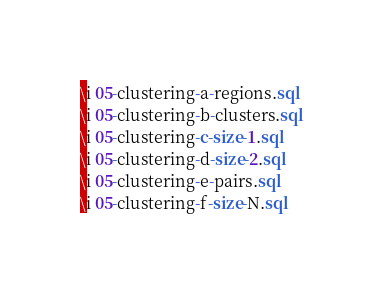<code> <loc_0><loc_0><loc_500><loc_500><_SQL_>\i 05-clustering-a-regions.sql
\i 05-clustering-b-clusters.sql
\i 05-clustering-c-size-1.sql
\i 05-clustering-d-size-2.sql
\i 05-clustering-e-pairs.sql
\i 05-clustering-f-size-N.sql
</code> 